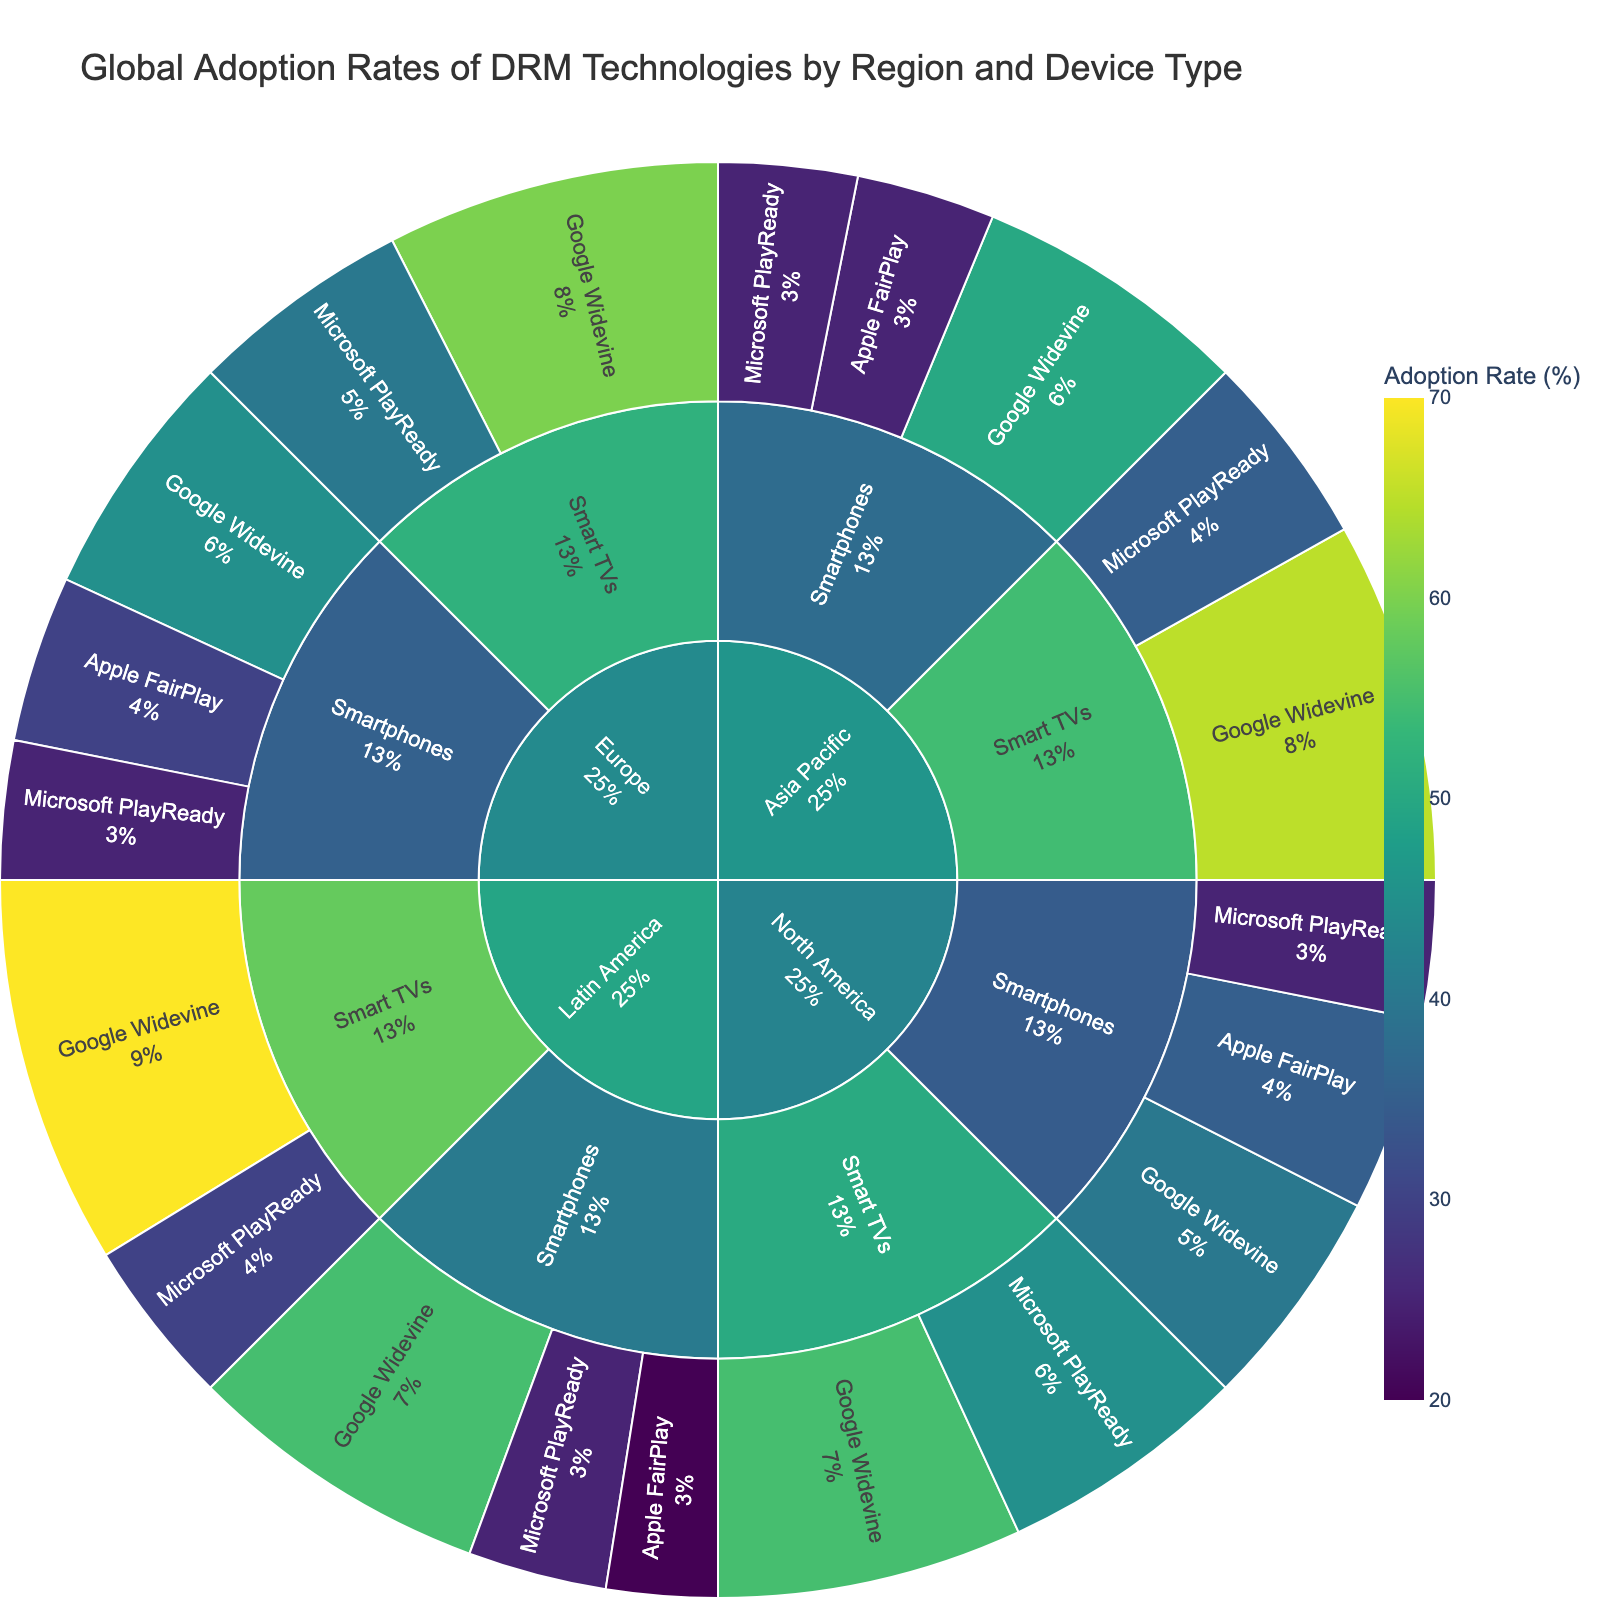what is the title of the figure? The title of the figure is usually located at the top of the plot and often describes the overall content or purpose of the visualization. In this case, the title is "Global Adoption Rates of DRM Technologies by Region and Device Type".
Answer: Global Adoption Rates of DRM Technologies by Region and Device Type which region has the highest adoption rate of Google Widevine on Smart TVs? To answer this question, we need to look at the arc segments under each region’s node for Smart TVs and check the Google Widevine segments. The region with the highest value will have the largest segment for Google Widevine on Smart TVs.
Answer: Latin America how does the adoption rate of Apple FairPlay on smartphones in North America compare to Europe and Asia Pacific? We need to compare the size of the segments representing the adoption rate of Apple FairPlay on smartphones for North America, Europe, and Asia Pacific. North America has 35%, Europe has 30%, and Asia Pacific has 25%.
Answer: North America > Europe > Asia Pacific what is the total adoption rate of all DRM technologies on Smart TVs in Europe? To find the total adoption rate for Smart TVs in Europe, sum the adoption rates of Google Widevine and Microsoft PlayReady on Smart TVs in Europe (60% and 40%, respectively). 60 + 40 = 100
Answer: 100% which device type has a higher adoption rate for Microsoft PlayReady in North America, Smart TVs or smartphones? Look at the adoption rate segments for Microsoft PlayReady in North America for both Smart TVs (45%) and smartphones (25%).
Answer: Smart TVs what is the least adopted DRM technology in Latin America across both device types? Check all segments under Latin America for both smartphones and Smart TVs. Apple FairPlay has the lowest adoption rate with 20% on smartphones.
Answer: Apple FairPlay compare the adoption rates of Google Widevine on smartphones in Asia Pacific and Latin America. Which is higher? Look at the Google Widevine segments on smartphones for both Asia Pacific (50%) and Latin America (55%).
Answer: Latin America what percentage of the global adoption rate does Google Widevine have on Smart TVs in the Asia Pacific region? This requires calculating the adoption rate of Google Widevine on Smart TVs as a percentage of the total adoption rates for that device type in the Asia Pacific region. Google Widevine has 65% on Smart TVs in Asia Pacific.
Answer: 65% if we sum the adoption rates of all DRM technologies on smartphones in North America, what is the total? Sum the adoption rates of Apple FairPlay, Google Widevine, and Microsoft PlayReady on smartphones in North America (35 + 40 + 25). 35 + 40 + 25 = 100
Answer: 100 which region shows equal adoption rates for Microsoft PlayReady on both smartphones and Smart TVs? Look for segments where the adoption rates of Microsoft PlayReady on both smartphones and Smart TVs are the same. None of the regions have equal adoption rates; they all show different values.
Answer: None 